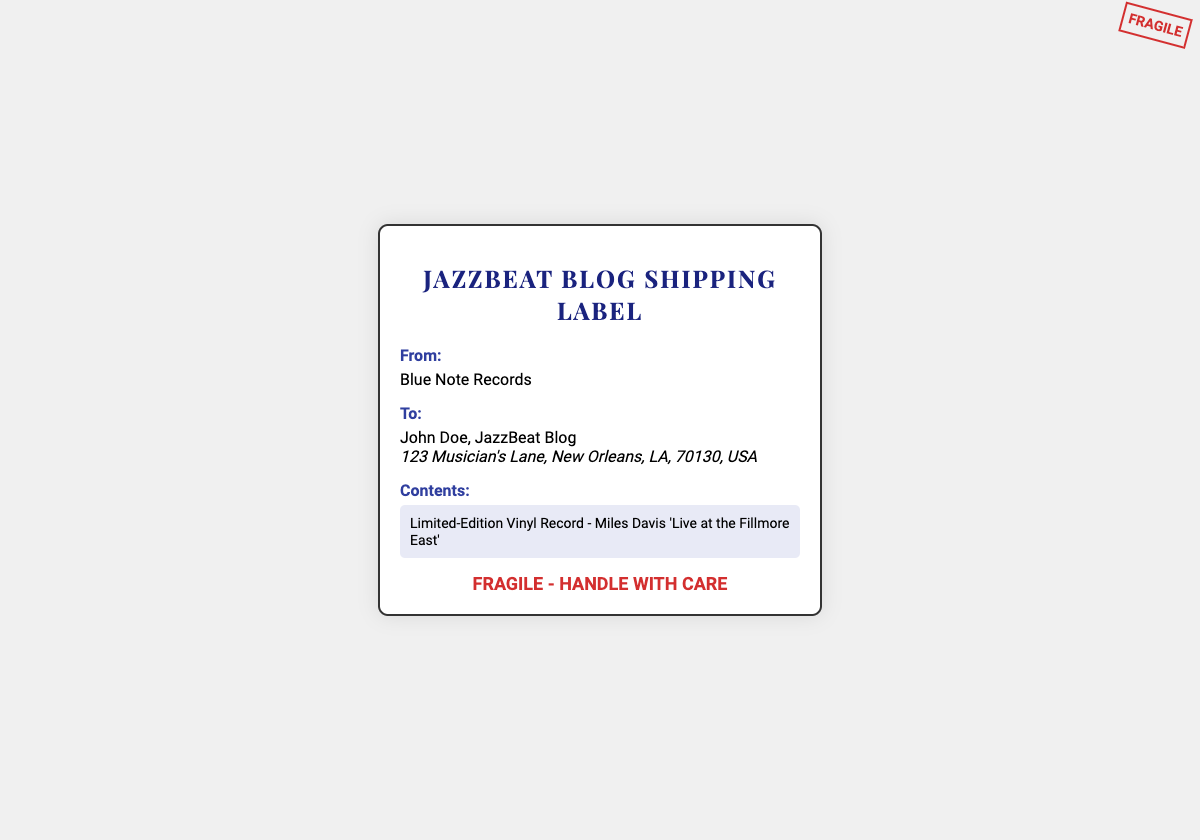What is the sender's name? The sender's name is listed at the top section of the document under "From".
Answer: Blue Note Records What is the recipient's name? The recipient's name is shown under "To" in the document.
Answer: John Doe, JazzBeat Blog What is the address for delivery? The address is presented in the address section, indicating where the package is to be sent.
Answer: 123 Musician's Lane, New Orleans, LA, 70130, USA What is the content of the shipment? The contents are detailed in the section that specifies what is being shipped.
Answer: Limited-Edition Vinyl Record - Miles Davis 'Live at the Fillmore East' What special handling instructions are noted? The instructions are clearly stated in the document for handling the package delicately.
Answer: Fragile - Handle with Care What type of item is being shipped? The type of item is indicated in the contents section of the label.
Answer: Vinyl Record What is the significance of the "FRAGILE" stamp? The stamp signifies that the item requires careful handling during transit.
Answer: Care What is the overall purpose of this document? This document serves as a shipping label for a specific music-related item.
Answer: Shipping label How is the document stylistically presented? The labels are designed with specific fonts and styles to highlight crucial information.
Answer: Elegant 